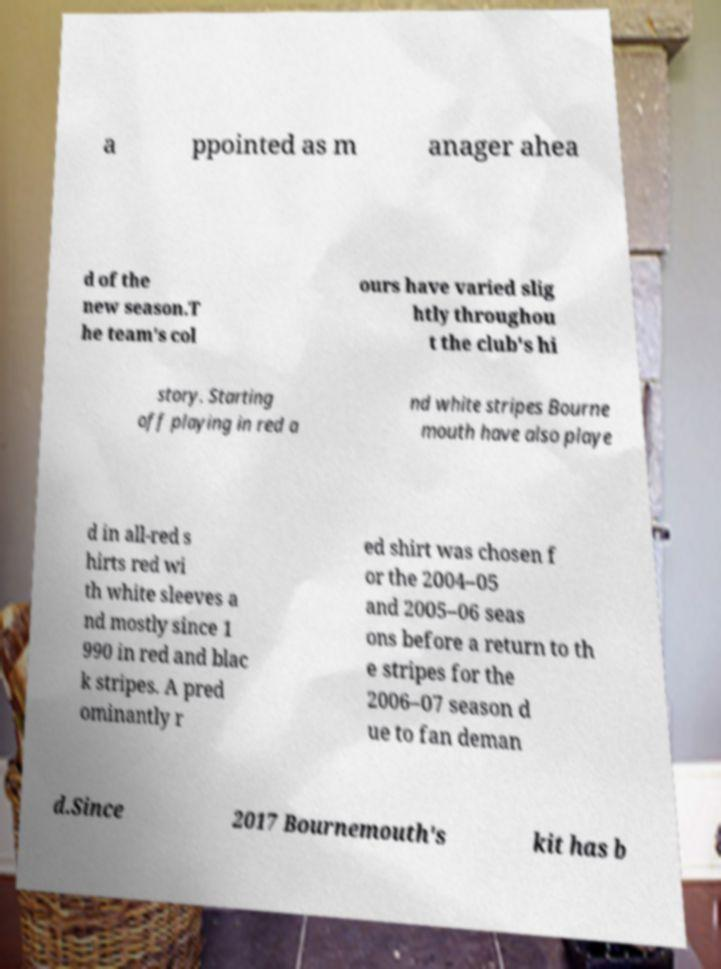Please read and relay the text visible in this image. What does it say? a ppointed as m anager ahea d of the new season.T he team's col ours have varied slig htly throughou t the club's hi story. Starting off playing in red a nd white stripes Bourne mouth have also playe d in all-red s hirts red wi th white sleeves a nd mostly since 1 990 in red and blac k stripes. A pred ominantly r ed shirt was chosen f or the 2004–05 and 2005–06 seas ons before a return to th e stripes for the 2006–07 season d ue to fan deman d.Since 2017 Bournemouth's kit has b 